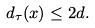<formula> <loc_0><loc_0><loc_500><loc_500>d _ { \tau } ( x ) \leq 2 d .</formula> 